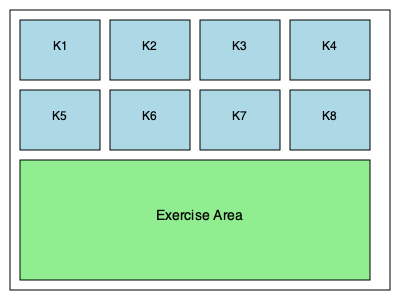Given the kennel layout shown in the floor plan, what is the optimal arrangement of dogs to minimize stress and maximize socialization, assuming there are 6 dogs of varying compatibility? Consider that dogs K1 and K3 are highly social, K2 and K5 are moderately social, and K4 and K6 prefer less interaction. Calculate the total number of possible arrangements and determine the best configuration for the dogs' well-being. To solve this problem, we need to follow these steps:

1. Analyze the kennel layout:
   - There are 8 individual kennels (K1-K8)
   - There is a shared exercise area

2. Consider the dogs' social preferences:
   - Highly social: K1 and K3
   - Moderately social: K2 and K5
   - Less social: K4 and K6

3. Calculate the total number of possible arrangements:
   - We have 6 dogs and 8 kennels
   - This can be calculated using the permutation formula:
     $P(8,6) = \frac{8!}{(8-6)!} = \frac{8!}{2!} = 20,160$

4. Determine the optimal arrangement:
   a. Place highly social dogs (K1 and K3) in kennels with the most neighboring kennels:
      - K2 and K6 are ideal as they have 3 neighboring kennels each
   b. Place moderately social dogs (K2 and K5) in kennels with 2 neighboring kennels:
      - K3 and K7 are suitable
   c. Place less social dogs (K4 and K6) in kennels with the least neighboring kennels:
      - K1 and K5 are ideal as they have only 2 neighboring kennels each

5. The optimal arrangement:
   - K1 (less social) in kennel K1
   - K2 (moderately social) in kennel K3
   - K3 (highly social) in kennel K2
   - K4 (less social) in kennel K5
   - K5 (moderately social) in kennel K7
   - K6 (highly social) in kennel K6

This arrangement maximizes socialization for social dogs, provides moderate interaction for moderately social dogs, and minimizes stress for less social dogs while allowing all dogs access to the shared exercise area.
Answer: K1 in K1, K2 in K3, K3 in K2, K4 in K5, K5 in K7, K6 in K6 